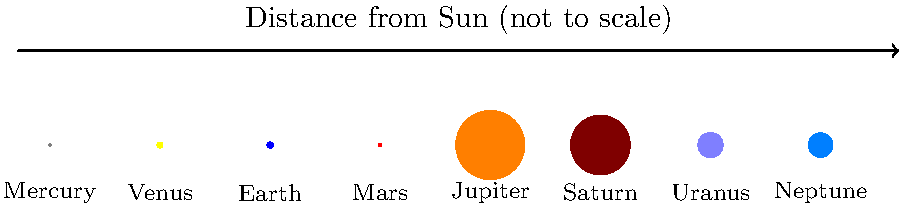As an entrepreneur developing an AI-powered baking robot, you understand the importance of precision in measurements. Similarly, in our solar system, the relative sizes and distances of planets are crucial. Looking at the diagram, which planet is both significantly larger than Earth and positioned between two gas giants? Let's approach this step-by-step:

1. First, we need to identify Earth in the diagram. Earth is the third planet from the left, colored blue.

2. We need to find planets that are significantly larger than Earth. Looking at the diagram, we can see that Jupiter (the 5th planet) and Saturn (the 6th planet) are much larger than Earth.

3. Now, we need to check if there's a large planet between these two gas giants. Indeed, there is - it's Jupiter itself.

4. To confirm, let's look at the planets on either side of Jupiter:
   - To its left is Mars, which is smaller than Earth
   - To its right is Saturn, another gas giant

5. Therefore, Jupiter is the only planet that fits all the criteria:
   - It's significantly larger than Earth (about 11 times Earth's diameter)
   - It's positioned between two gas giants (itself and Saturn)

This question relates to your AI baking robot in terms of understanding relative sizes and positions, which could be crucial in programming precise movements and measurements for baking processes.
Answer: Jupiter 